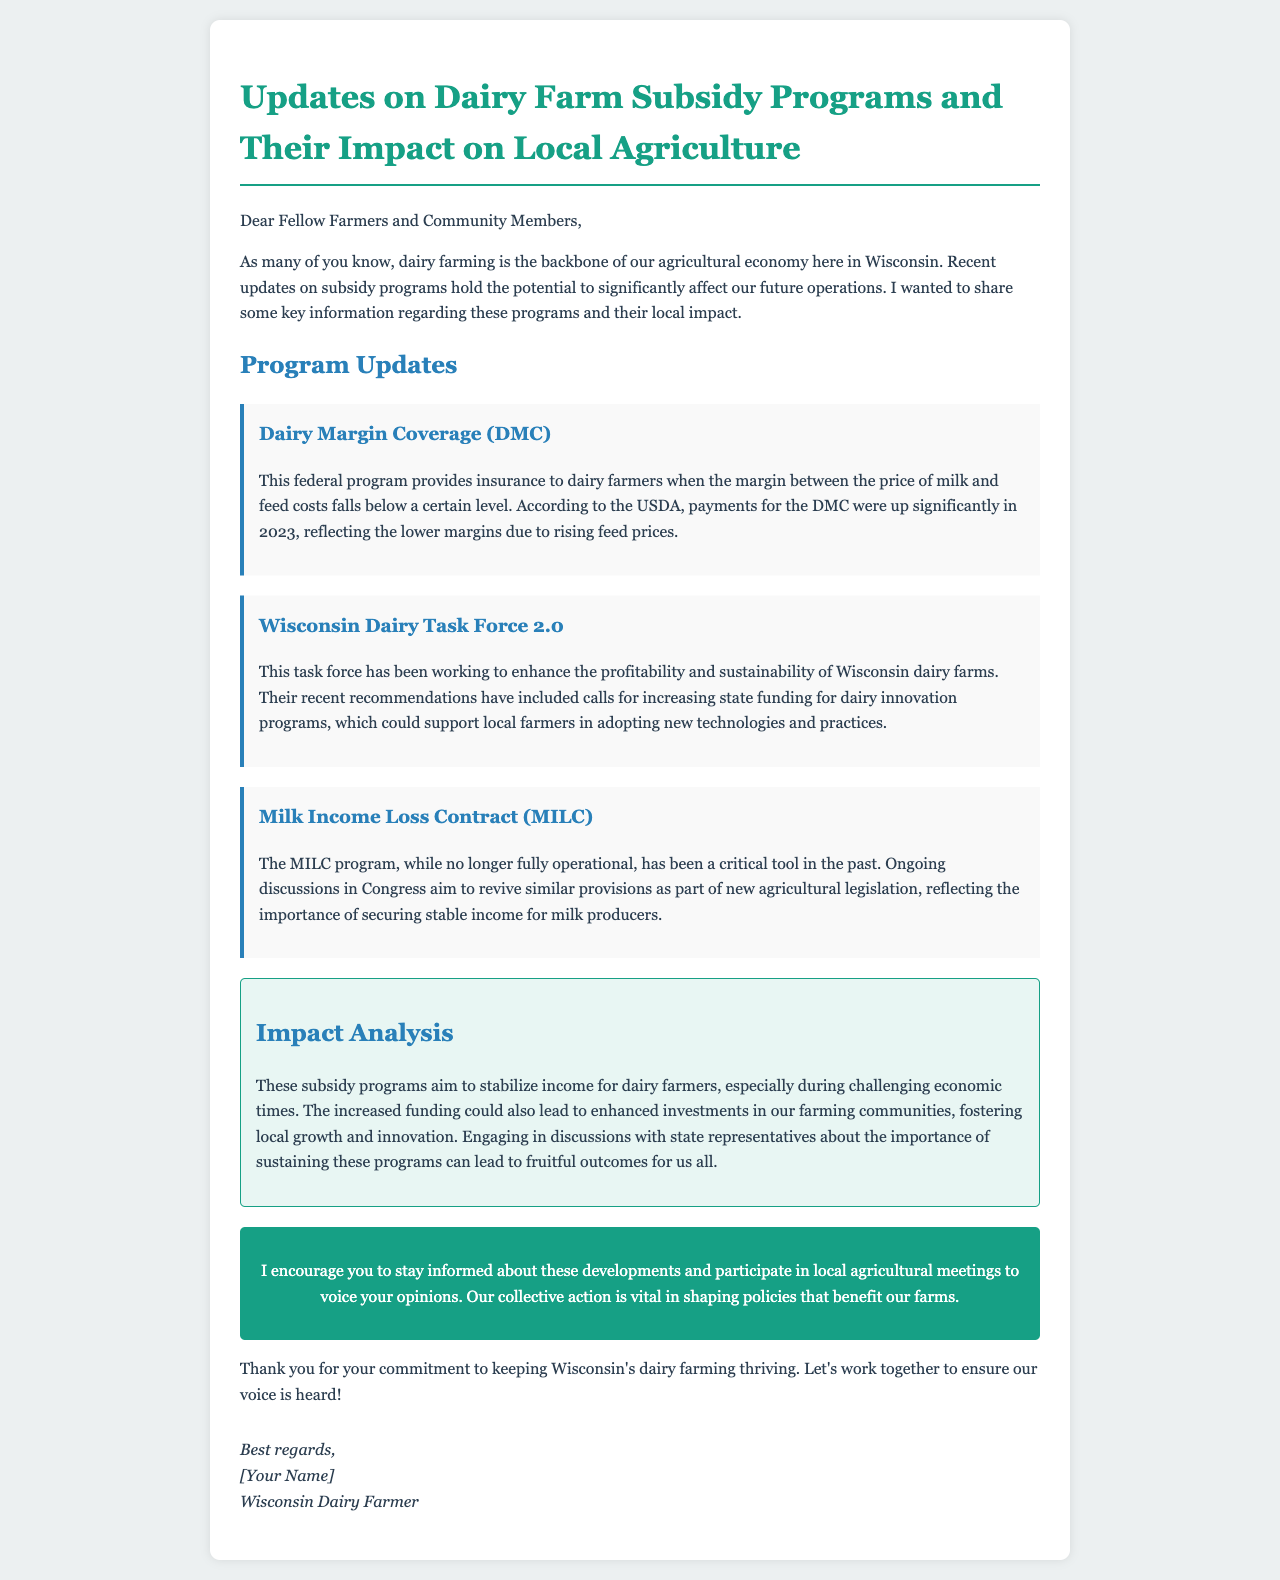What is the name of the federal program providing insurance to dairy farmers? The program is mentioned as a specific federal initiative that offers insurance to dairy farmers when margins fall below a certain level.
Answer: Dairy Margin Coverage (DMC) What significant change occurred with the DMC payments in 2023? The document states that payments for the DMC were notably higher in 2023 due to lower margins affected by rising feed prices.
Answer: Payments increased What recommendations did Wisconsin Dairy Task Force 2.0 make? The document discusses the task force's suggestions for state funding to aid in dairy innovation programs aimed at supporting local farmers.
Answer: Increase state funding Is the MILC program currently fully operational? The email clarifies the status of the MILC program and mentions that it is not fully operational but references ongoing discussions regarding its revival.
Answer: No What do the subsidy programs aim to achieve for dairy farmers? The document outlines that these programs are designed to stabilize income for dairy farmers, especially in tough economic times.
Answer: Stabilize income How should farmers engage regarding the subsidy programs? The document encourages collective action by participating in local agricultural meetings to influence policies beneficial to farms.
Answer: Participate in local meetings What is the primary focus of the email? The purpose of the email is to provide updates on specific subsidy programs and their implications for local agriculture, particularly dairy farming in Wisconsin.
Answer: Updates on subsidy programs What is suggested as a critical action by farmers in the email? The document emphasizes that staying informed and engaged in discussions is vital for shaping policies that affect dairy farms.
Answer: Stay informed and engage 